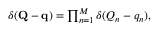Convert formula to latex. <formula><loc_0><loc_0><loc_500><loc_500>\begin{array} { r } { \delta ( Q - q ) = \prod _ { n = 1 } ^ { M } \delta ( Q _ { n } - q _ { n } ) , } \end{array}</formula> 